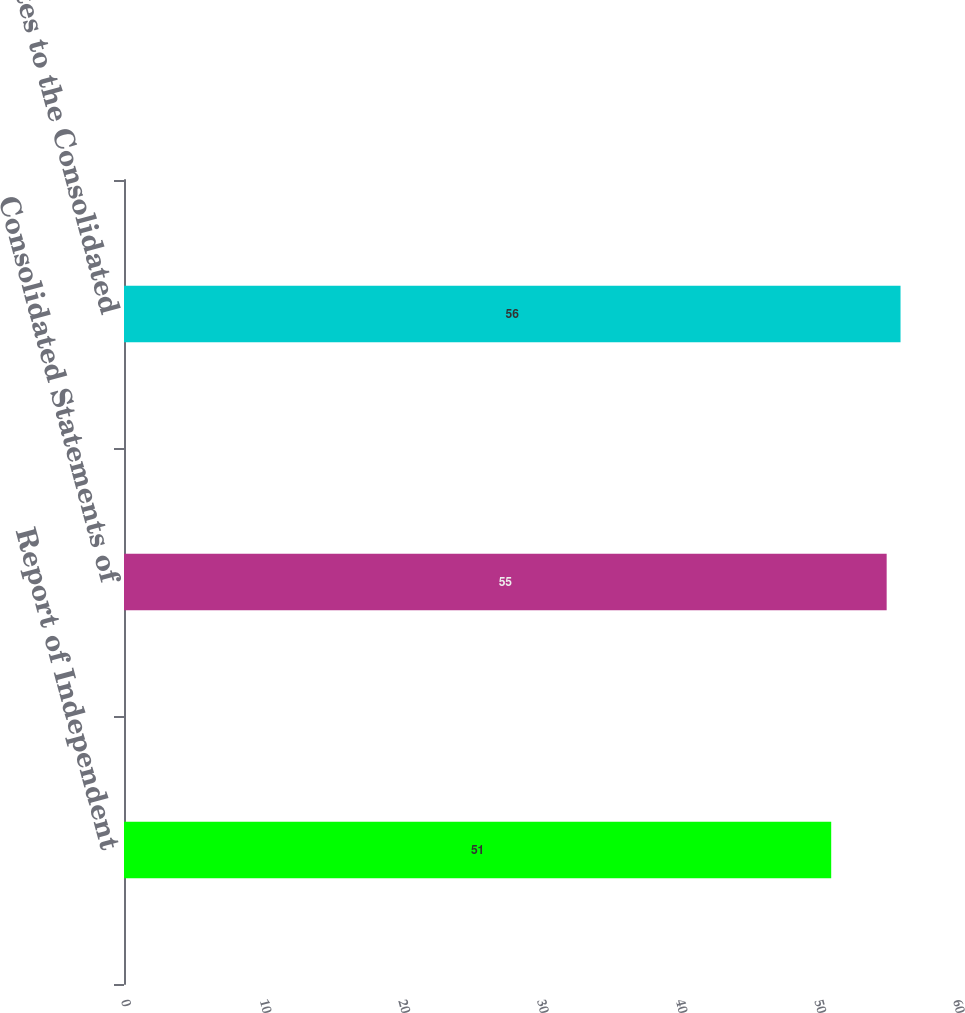Convert chart. <chart><loc_0><loc_0><loc_500><loc_500><bar_chart><fcel>Report of Independent<fcel>Consolidated Statements of<fcel>Notes to the Consolidated<nl><fcel>51<fcel>55<fcel>56<nl></chart> 